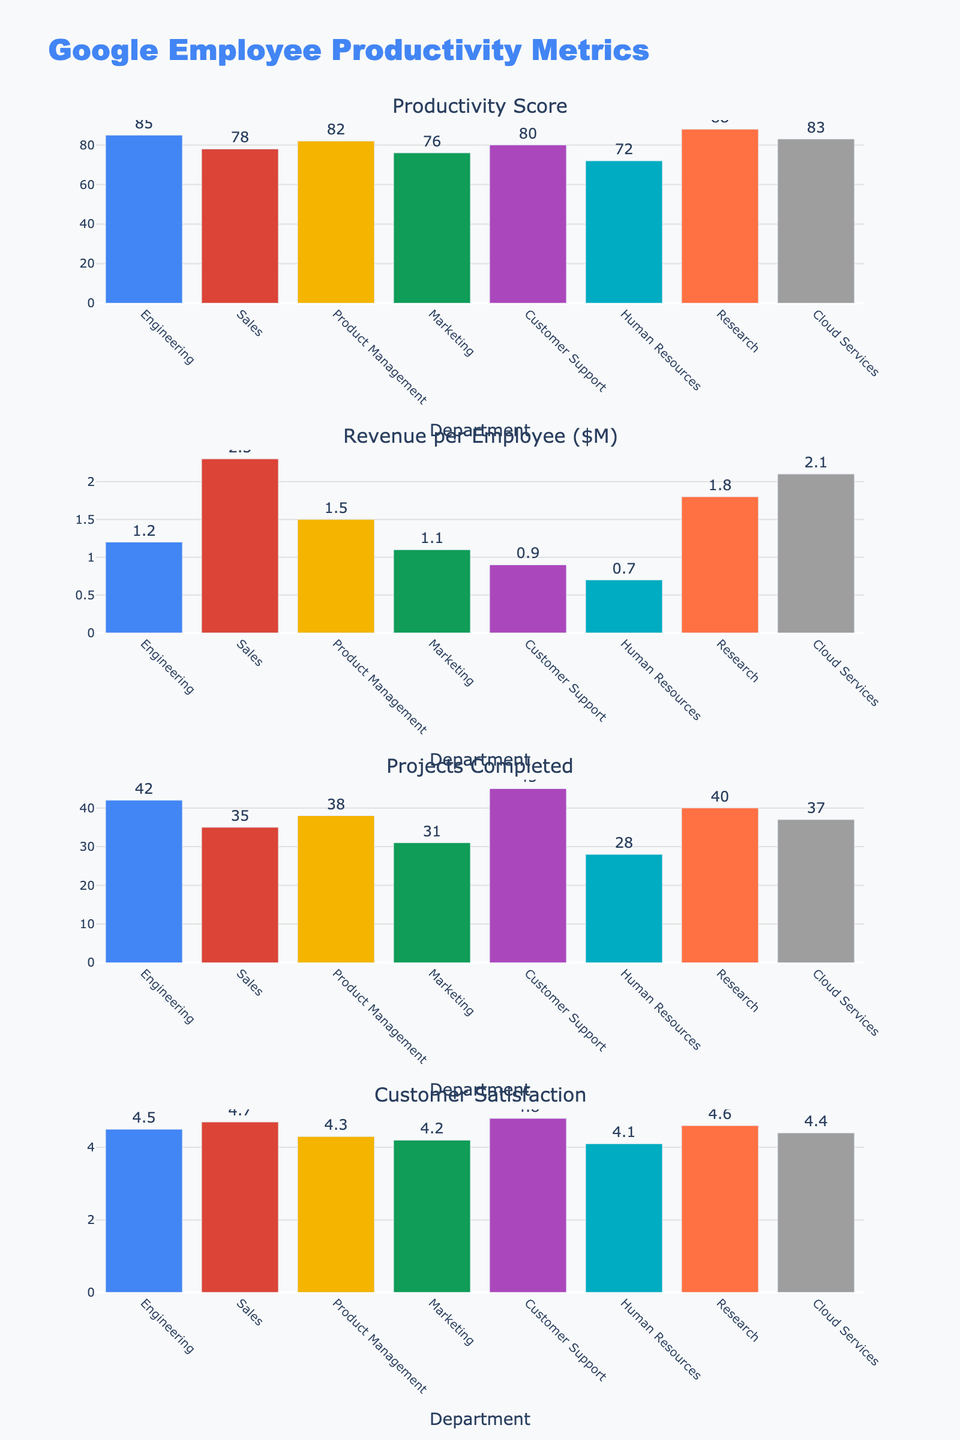How many projects did the Marketing department complete? Refer to the "Projects Completed" subplot and find the bar corresponding to the Marketing department. This bar displays the number 31.
Answer: 31 What is the customer satisfaction score for Customer Support? Look at the "Customer Satisfaction" subplot and find the bar for Customer Support. The bar indicates a customer satisfaction score of 4.8.
Answer: 4.8 What is the average Revenue per Employee across all departments? Sum all the values in the "Revenue per Employee ($M)" subplot: 1.2 (Engineering) + 2.3 (Sales) + 1.5 (Product Management) + 1.1 (Marketing) + 0.9 (Customer Support) + 0.7 (Human Resources) + 1.8 (Research) + 2.1 (Cloud Services) = 11.6. Divide the sum by the number of departments (8).
Answer: 1.45 Which department completed more projects, Engineering or Research? Compare the bars in the "Projects Completed" subplot. Engineering completed 42 projects while Research completed 40 projects. Engineering has the higher value.
Answer: Engineering Is the customer satisfaction score for Marketing higher than Product Management? Check the "Customer Satisfaction" subplot. The customer satisfaction score for Marketing is 4.2, and for Product Management, it is 4.3. The Marketing score is lower than that for Product Management.
Answer: No How does the productivity score of the Sales department compare to that of Cloud Services? Review the "Productivity Score" subplot. The Sales department has a score of 78, and Cloud Services has a score of 83. The Cloud Services score is higher.
Answer: Cloud Services Which department has the closest customer satisfaction score to 4.6? Identify the bars in the "Customer Satisfaction" subplot. The Research department has a customer satisfaction score of 4.6, matching the target value.
Answer: Research 